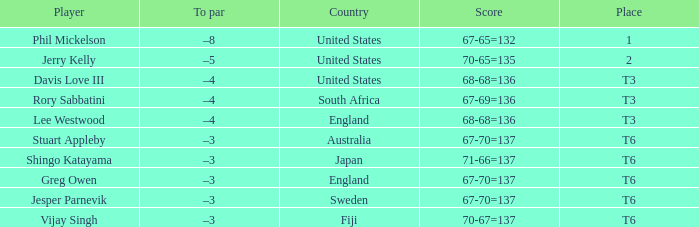Name the score for vijay singh 70-67=137. 